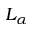<formula> <loc_0><loc_0><loc_500><loc_500>L _ { \alpha }</formula> 